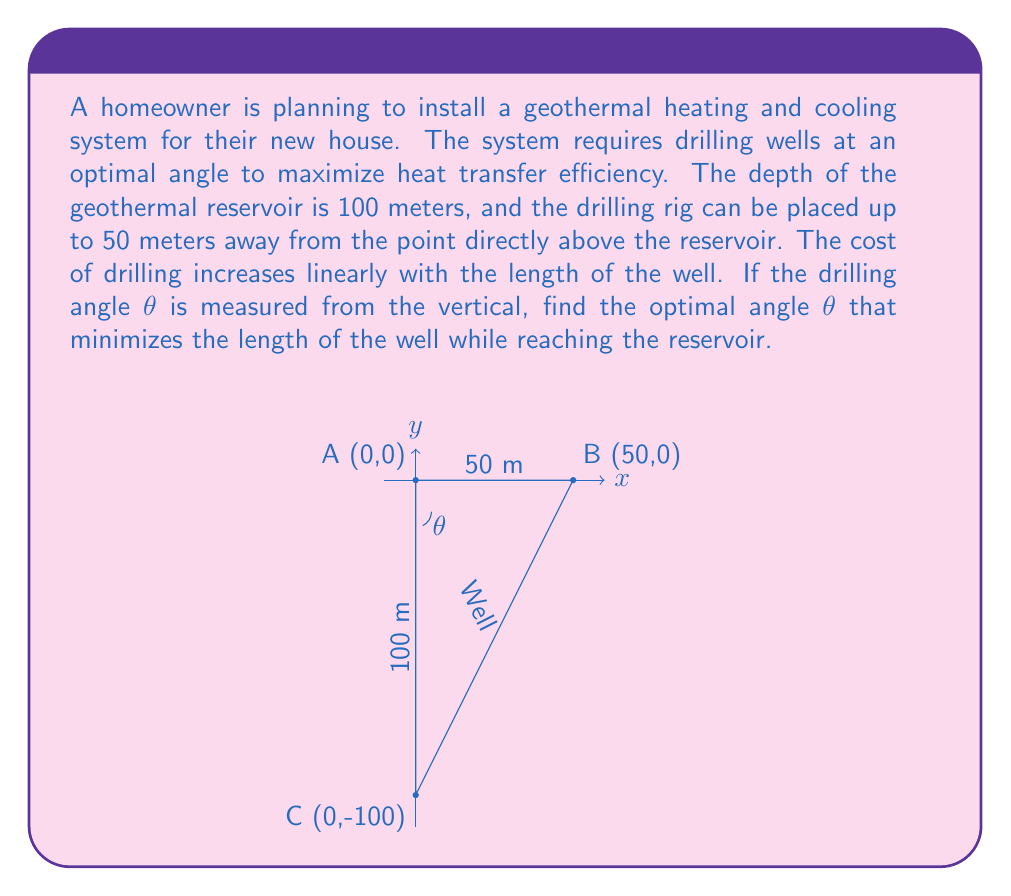Help me with this question. To solve this problem, we'll use trigonometry and calculus to minimize the length of the well.

1) Let's define the well length as L. Using the Pythagorean theorem, we can express L in terms of θ:

   $$L^2 = x^2 + y^2$$

   where x is the horizontal distance and y is the vertical depth.

2) We know that y = 100 m (depth of the reservoir). We can express x in terms of θ:

   $$\tan θ = \frac{x}{100}$$
   $$x = 100 \tan θ$$

3) Substituting these into the Pythagorean theorem:

   $$L^2 = (100 \tan θ)^2 + 100^2$$
   $$L = \sqrt{10000 \tan^2 θ + 10000}$$
   $$L = 100\sqrt{\tan^2 θ + 1}$$

4) To minimize L, we need to find where its derivative with respect to θ is zero. However, it's often easier to minimize L^2 instead, which will give the same result:

   $$L^2 = 10000(\tan^2 θ + 1)$$

5) Taking the derivative of L^2 with respect to θ:

   $$\frac{d(L^2)}{dθ} = 20000 \tan θ \sec^2 θ$$

6) Setting this equal to zero:

   $$20000 \tan θ \sec^2 θ = 0$$

   This is true when $\tan θ = 0$, which occurs when $θ = 0°$ or $θ = 180°$. However, $θ = 180°$ is not physically possible in this context.

7) To confirm this is a minimum, we can check the second derivative:

   $$\frac{d^2(L^2)}{dθ^2} = 20000 (\sec^2 θ + 2\tan^2 θ \sec^2 θ)$$

   This is always positive for real θ, confirming that θ = 0° is indeed a minimum.

8) However, we need to consider the constraint that the drilling rig can be placed up to 50 meters away. This means:

   $$100 \tan θ ≤ 50$$
   $$\tan θ ≤ 0.5$$
   $$θ ≤ \arctan(0.5) ≈ 26.57°$$

Therefore, the optimal angle is the smallest possible angle that satisfies our constraints, which is 0°.
Answer: The optimal drilling angle θ is 0° (vertical), which minimizes the length of the well while reaching the reservoir. 